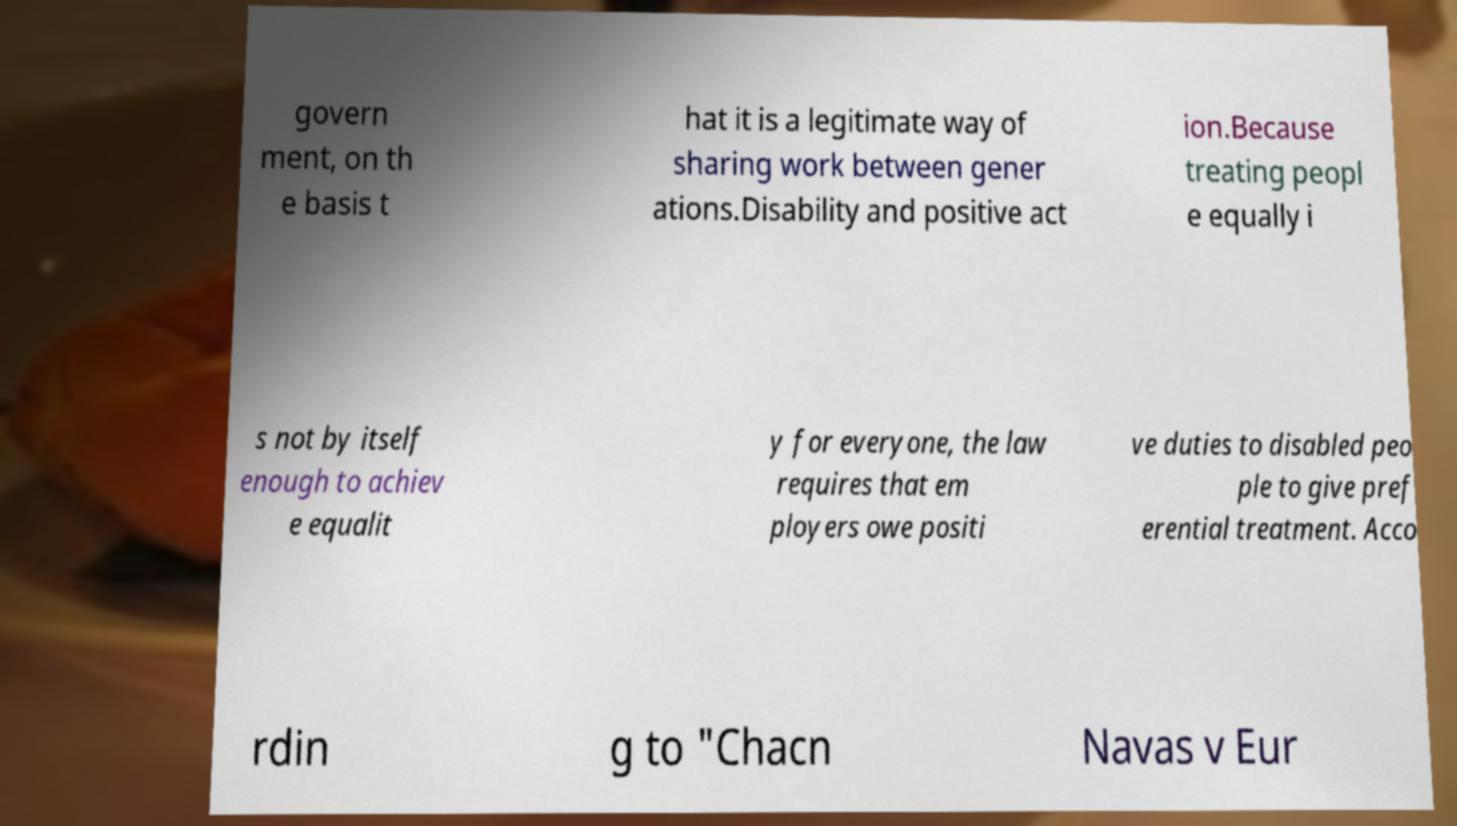I need the written content from this picture converted into text. Can you do that? govern ment, on th e basis t hat it is a legitimate way of sharing work between gener ations.Disability and positive act ion.Because treating peopl e equally i s not by itself enough to achiev e equalit y for everyone, the law requires that em ployers owe positi ve duties to disabled peo ple to give pref erential treatment. Acco rdin g to "Chacn Navas v Eur 